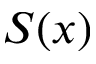<formula> <loc_0><loc_0><loc_500><loc_500>S ( x )</formula> 